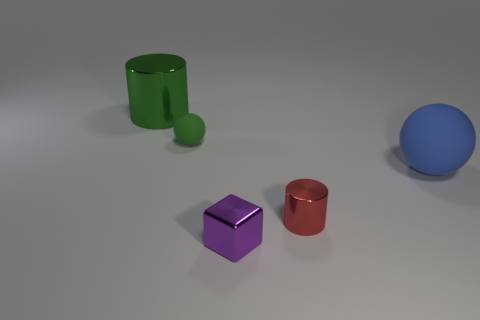Add 5 small green matte blocks. How many objects exist? 10 Subtract 1 cylinders. How many cylinders are left? 1 Subtract all cylinders. How many objects are left? 3 Subtract all tiny red metal cylinders. Subtract all blocks. How many objects are left? 3 Add 4 small shiny objects. How many small shiny objects are left? 6 Add 3 tiny red objects. How many tiny red objects exist? 4 Subtract 0 purple cylinders. How many objects are left? 5 Subtract all yellow balls. Subtract all yellow cylinders. How many balls are left? 2 